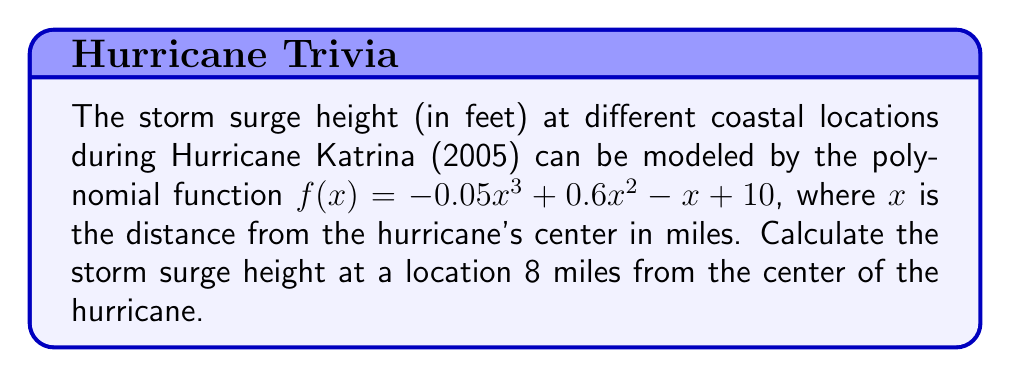Can you answer this question? To solve this problem, we need to evaluate the given polynomial function at $x = 8$. Let's break it down step-by-step:

1) The given function is $f(x) = -0.05x^3 + 0.6x^2 - x + 10$

2) We need to calculate $f(8)$, so we substitute $x$ with 8:

   $f(8) = -0.05(8^3) + 0.6(8^2) - 8 + 10$

3) Let's evaluate each term:
   
   a) $-0.05(8^3) = -0.05(512) = -25.6$
   b) $0.6(8^2) = 0.6(64) = 38.4$
   c) $-8$
   d) $10$

4) Now, we add all these terms:

   $f(8) = -25.6 + 38.4 - 8 + 10 = 14.8$

Therefore, the storm surge height at a location 8 miles from the center of Hurricane Katrina is 14.8 feet.
Answer: $14.8$ feet 